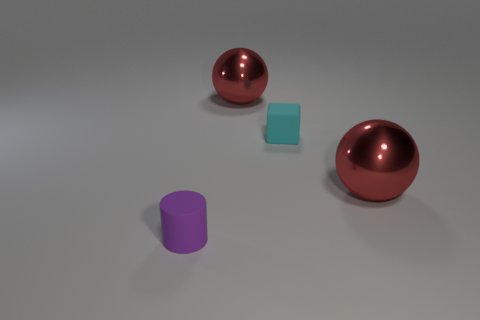Add 2 cyan rubber blocks. How many objects exist? 6 Subtract all cubes. How many objects are left? 3 Add 2 small rubber things. How many small rubber things are left? 4 Add 1 small cyan things. How many small cyan things exist? 2 Subtract 1 cyan blocks. How many objects are left? 3 Subtract all big red spheres. Subtract all small cylinders. How many objects are left? 1 